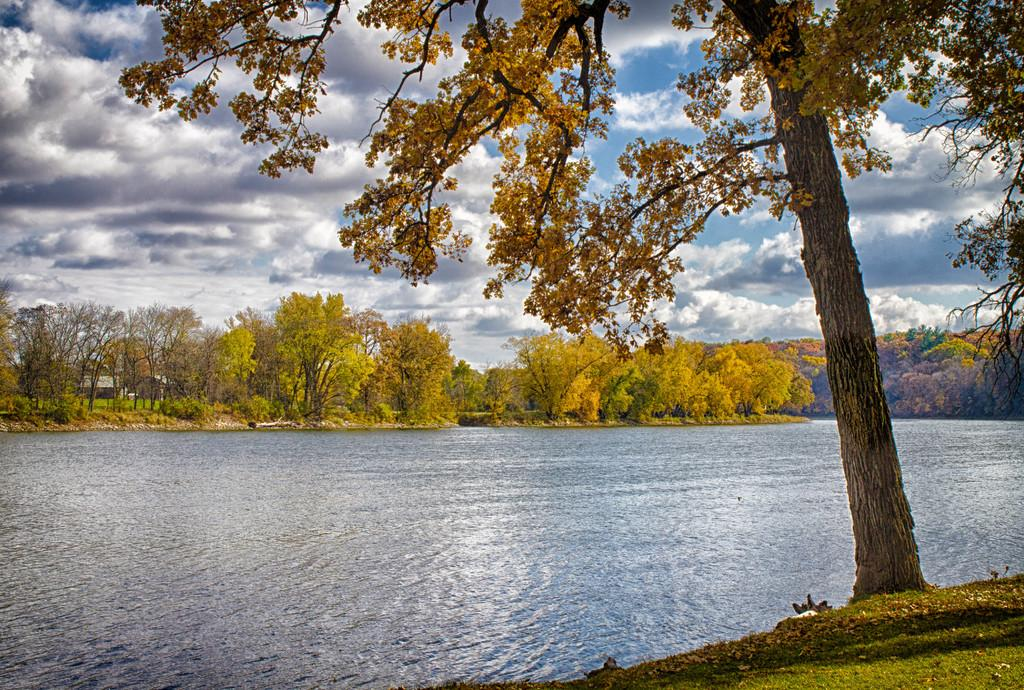What type of vegetation is visible in the image? There are trees and plants visible in the image. What natural element can be seen in the image? There is water visible in the image. What is visible in the sky in the image? There are clouds in the sky in the image. What type of oil can be seen floating on the water in the image? There is no oil visible in the image; only water is present. What type of sun is visible in the image? There is no specific type of sun visible in the image; it is simply the sun in the sky. 